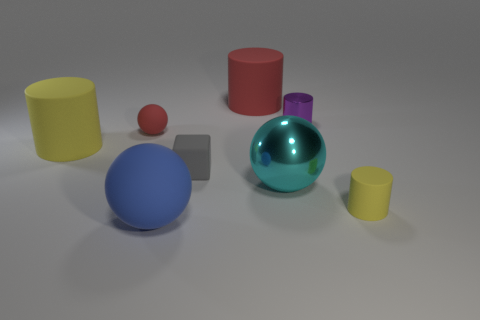Does the cyan object have the same shape as the small red thing? Yes, the cyan object, which is a cylinder, has the same three-dimensional shape as the small red object; they are both cylinders. However, their sizes differ, with the cyan cylinder being larger. 